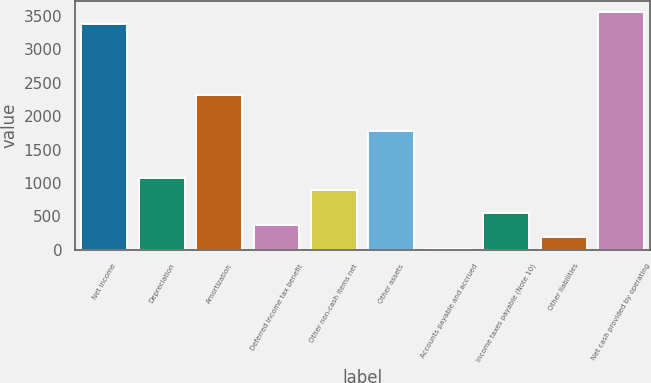Convert chart to OTSL. <chart><loc_0><loc_0><loc_500><loc_500><bar_chart><fcel>Net income<fcel>Depreciation<fcel>Amortization<fcel>Deferred income tax benefit<fcel>Other non-cash items net<fcel>Other assets<fcel>Accounts payable and accrued<fcel>Income taxes payable (Note 10)<fcel>Other liabilities<fcel>Net cash provided by operating<nl><fcel>3375.3<fcel>1075.6<fcel>2313.9<fcel>368<fcel>898.7<fcel>1783.2<fcel>14.2<fcel>544.9<fcel>191.1<fcel>3552.2<nl></chart> 